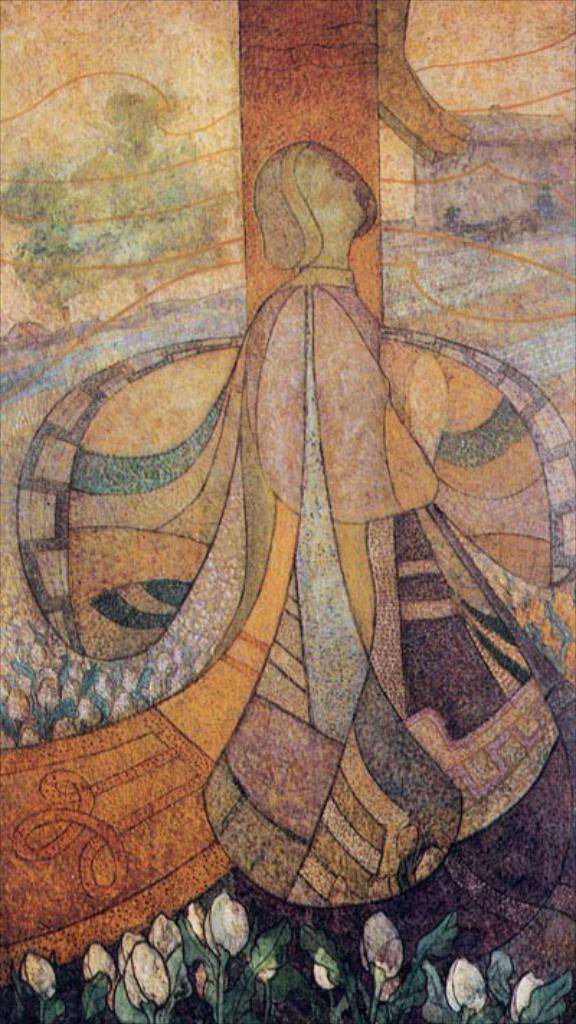What is the main subject of the image? The main subject of the image is an art piece. How many times does the art piece twist in the image? There is no information about the art piece twisting in the image. How many days have passed since the art piece was created in the image? There is no information about when the art piece was created in the image. What type of furniture is present in the image? There is no furniture present in the image; the main subject is an art piece. 